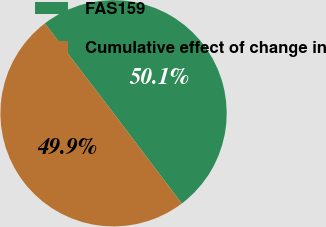<chart> <loc_0><loc_0><loc_500><loc_500><pie_chart><fcel>FAS159<fcel>Cumulative effect of change in<nl><fcel>50.09%<fcel>49.91%<nl></chart> 